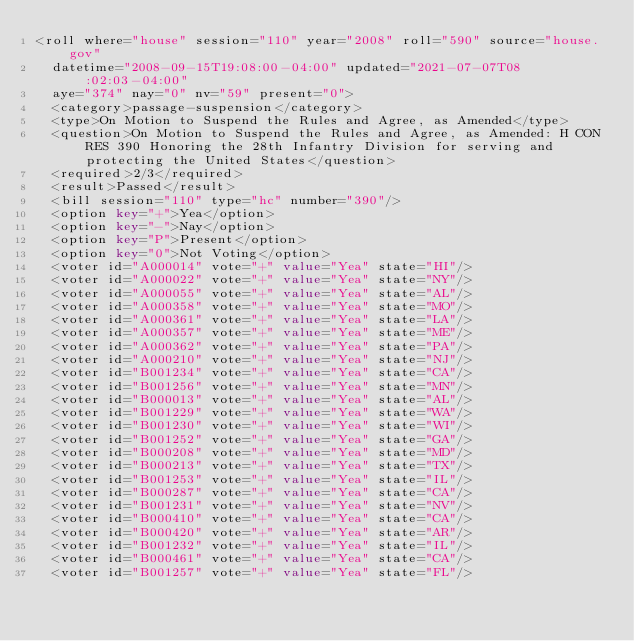Convert code to text. <code><loc_0><loc_0><loc_500><loc_500><_XML_><roll where="house" session="110" year="2008" roll="590" source="house.gov"
  datetime="2008-09-15T19:08:00-04:00" updated="2021-07-07T08:02:03-04:00"
  aye="374" nay="0" nv="59" present="0">
  <category>passage-suspension</category>
  <type>On Motion to Suspend the Rules and Agree, as Amended</type>
  <question>On Motion to Suspend the Rules and Agree, as Amended: H CON RES 390 Honoring the 28th Infantry Division for serving and protecting the United States</question>
  <required>2/3</required>
  <result>Passed</result>
  <bill session="110" type="hc" number="390"/>
  <option key="+">Yea</option>
  <option key="-">Nay</option>
  <option key="P">Present</option>
  <option key="0">Not Voting</option>
  <voter id="A000014" vote="+" value="Yea" state="HI"/>
  <voter id="A000022" vote="+" value="Yea" state="NY"/>
  <voter id="A000055" vote="+" value="Yea" state="AL"/>
  <voter id="A000358" vote="+" value="Yea" state="MO"/>
  <voter id="A000361" vote="+" value="Yea" state="LA"/>
  <voter id="A000357" vote="+" value="Yea" state="ME"/>
  <voter id="A000362" vote="+" value="Yea" state="PA"/>
  <voter id="A000210" vote="+" value="Yea" state="NJ"/>
  <voter id="B001234" vote="+" value="Yea" state="CA"/>
  <voter id="B001256" vote="+" value="Yea" state="MN"/>
  <voter id="B000013" vote="+" value="Yea" state="AL"/>
  <voter id="B001229" vote="+" value="Yea" state="WA"/>
  <voter id="B001230" vote="+" value="Yea" state="WI"/>
  <voter id="B001252" vote="+" value="Yea" state="GA"/>
  <voter id="B000208" vote="+" value="Yea" state="MD"/>
  <voter id="B000213" vote="+" value="Yea" state="TX"/>
  <voter id="B001253" vote="+" value="Yea" state="IL"/>
  <voter id="B000287" vote="+" value="Yea" state="CA"/>
  <voter id="B001231" vote="+" value="Yea" state="NV"/>
  <voter id="B000410" vote="+" value="Yea" state="CA"/>
  <voter id="B000420" vote="+" value="Yea" state="AR"/>
  <voter id="B001232" vote="+" value="Yea" state="IL"/>
  <voter id="B000461" vote="+" value="Yea" state="CA"/>
  <voter id="B001257" vote="+" value="Yea" state="FL"/></code> 